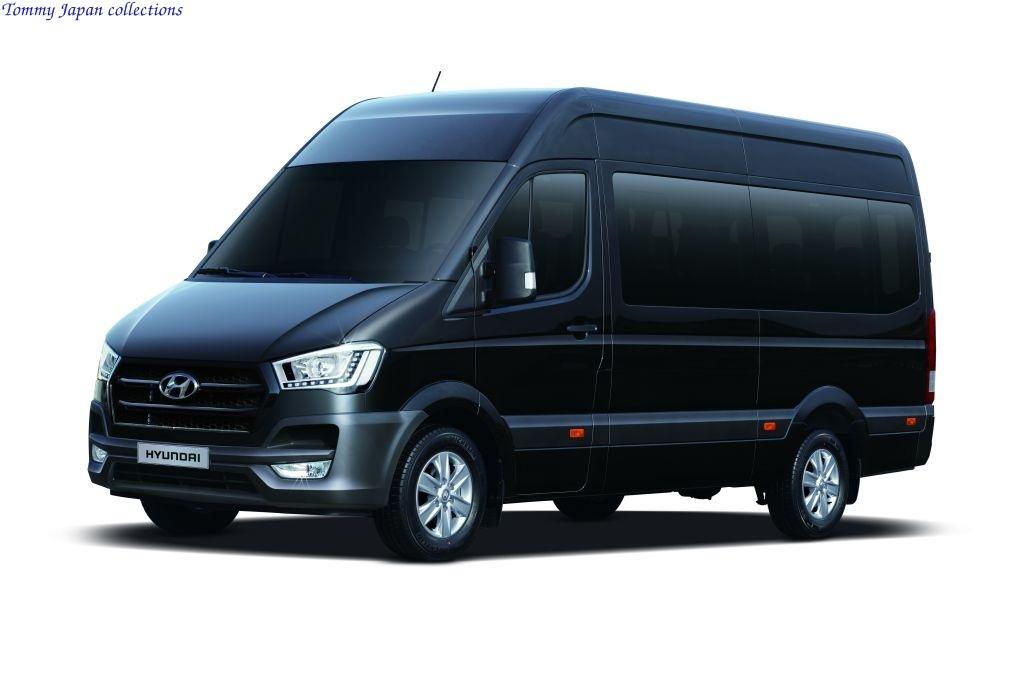What is the main subject of the image? There is a vehicle in the image. What color is the vehicle? The vehicle is black in color. What can be seen in the background of the image? The background of the image is white. What type of fuel is the vehicle using in the image? There is no information about the type of fuel the vehicle is using in the image. Can you see the vehicle's father in the image? There is no person, including a father, present in the image. 